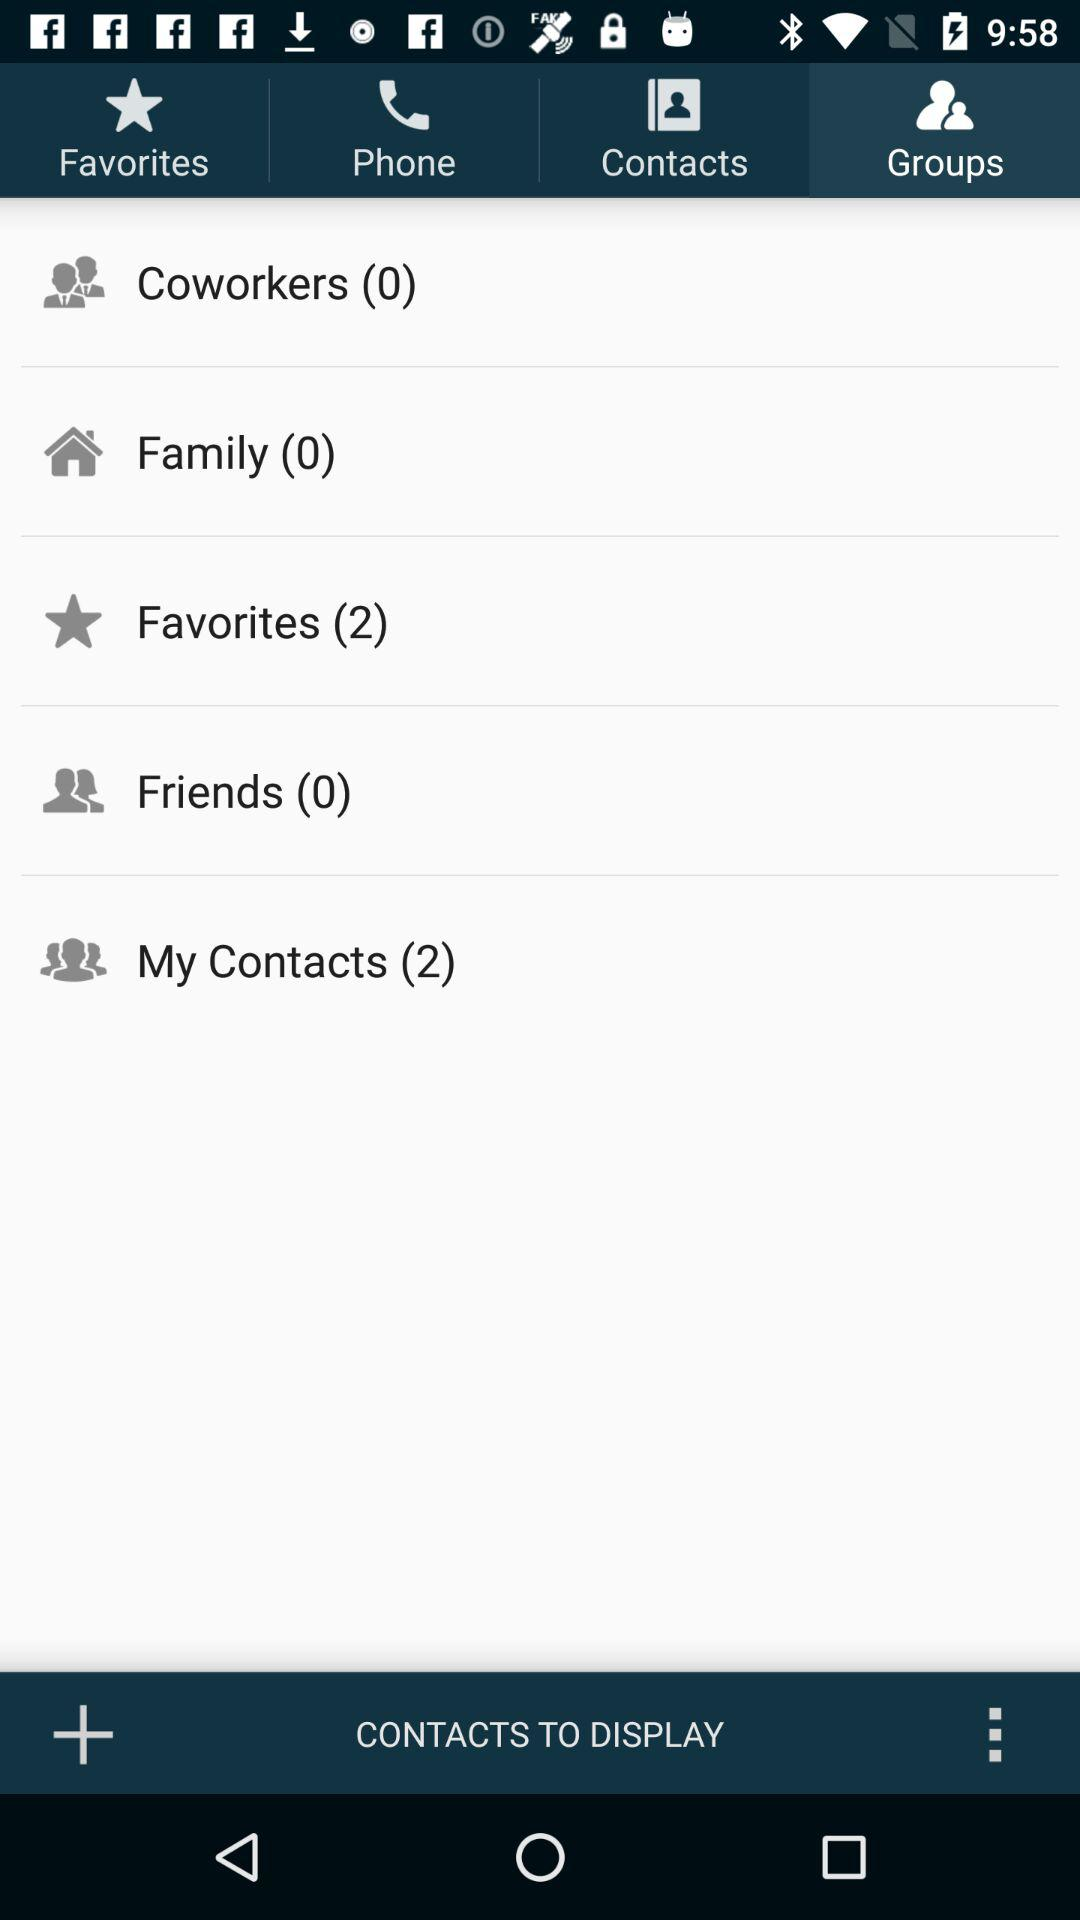How many contacts are there in the "My Contacts" section? The number of contacts is 2. 